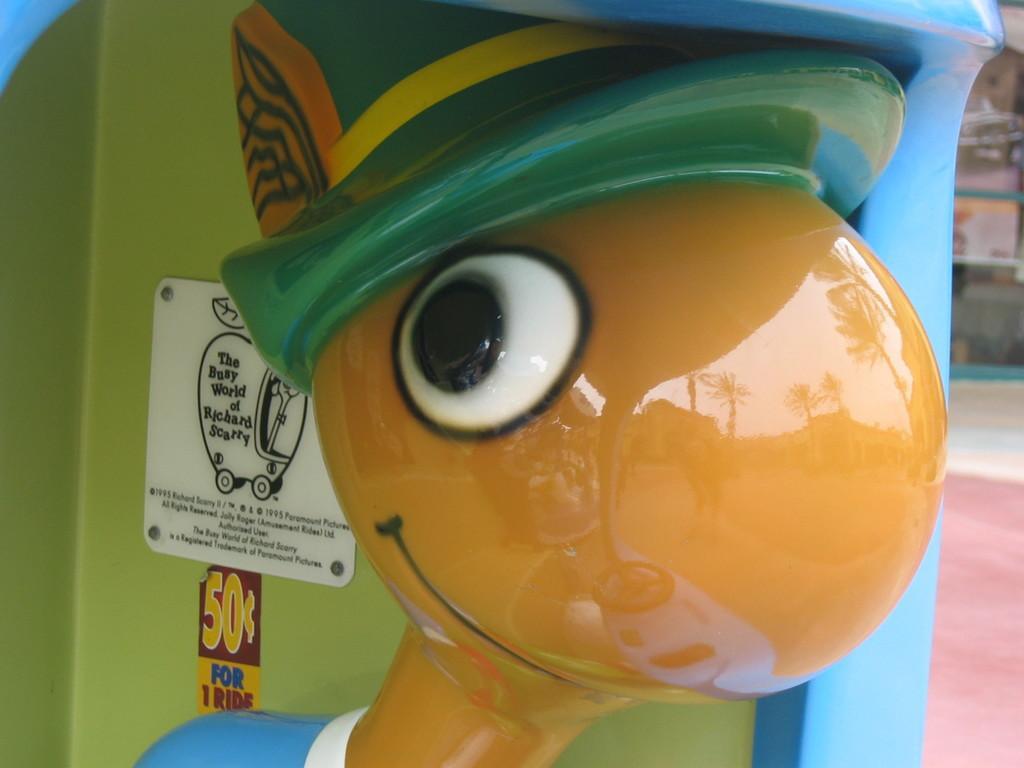Can you describe this image briefly? In this picture we can see a toy and behind the toy there is a sticker, board and screws. On the toy we can see the reflection of trees and the sky. 